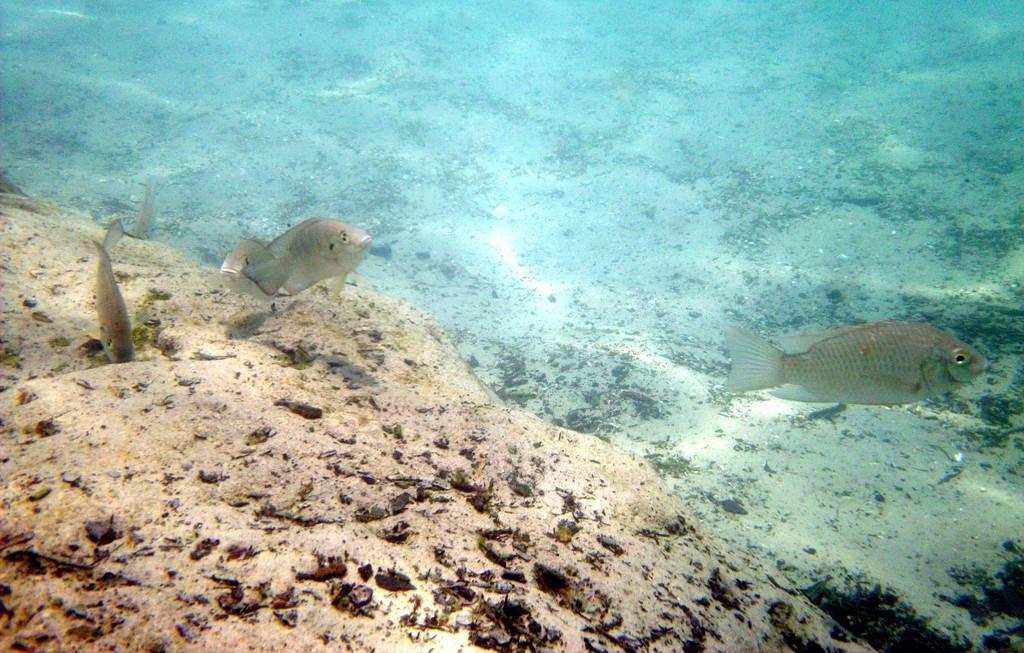Can you describe this image briefly? In this image we can see fishes in the water, here is the sand. 